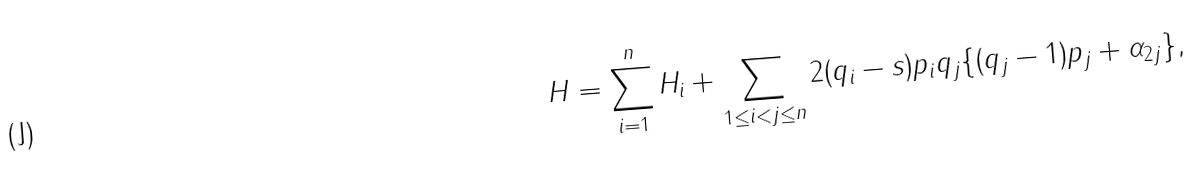Convert formula to latex. <formula><loc_0><loc_0><loc_500><loc_500>H = \sum _ { i = 1 } ^ { n } H _ { i } + \sum _ { 1 \leq i < j \leq n } 2 ( q _ { i } - s ) p _ { i } q _ { j } \{ ( q _ { j } - 1 ) p _ { j } + \alpha _ { 2 j } \} ,</formula> 